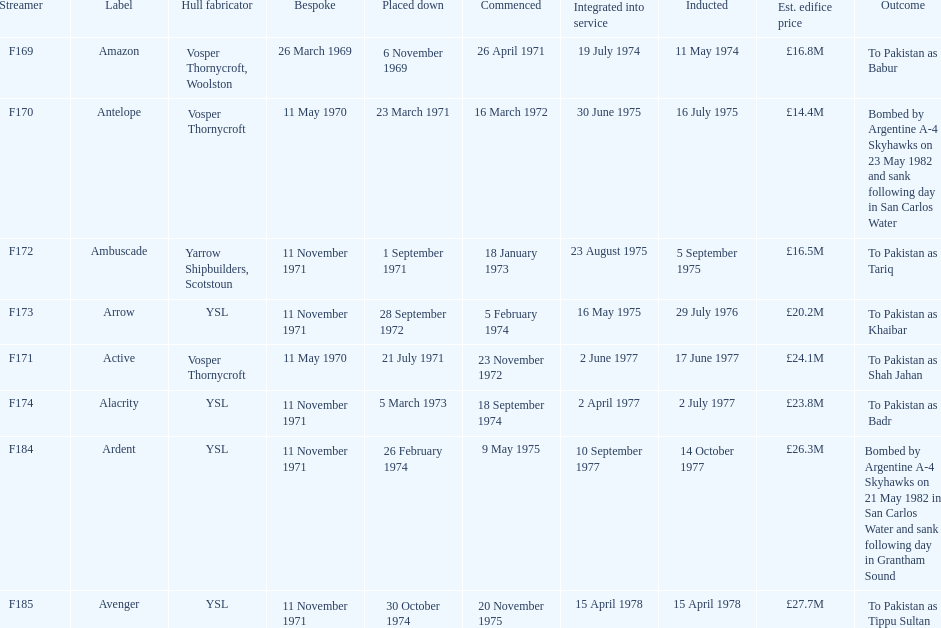How many ships were built after ardent? 1. 